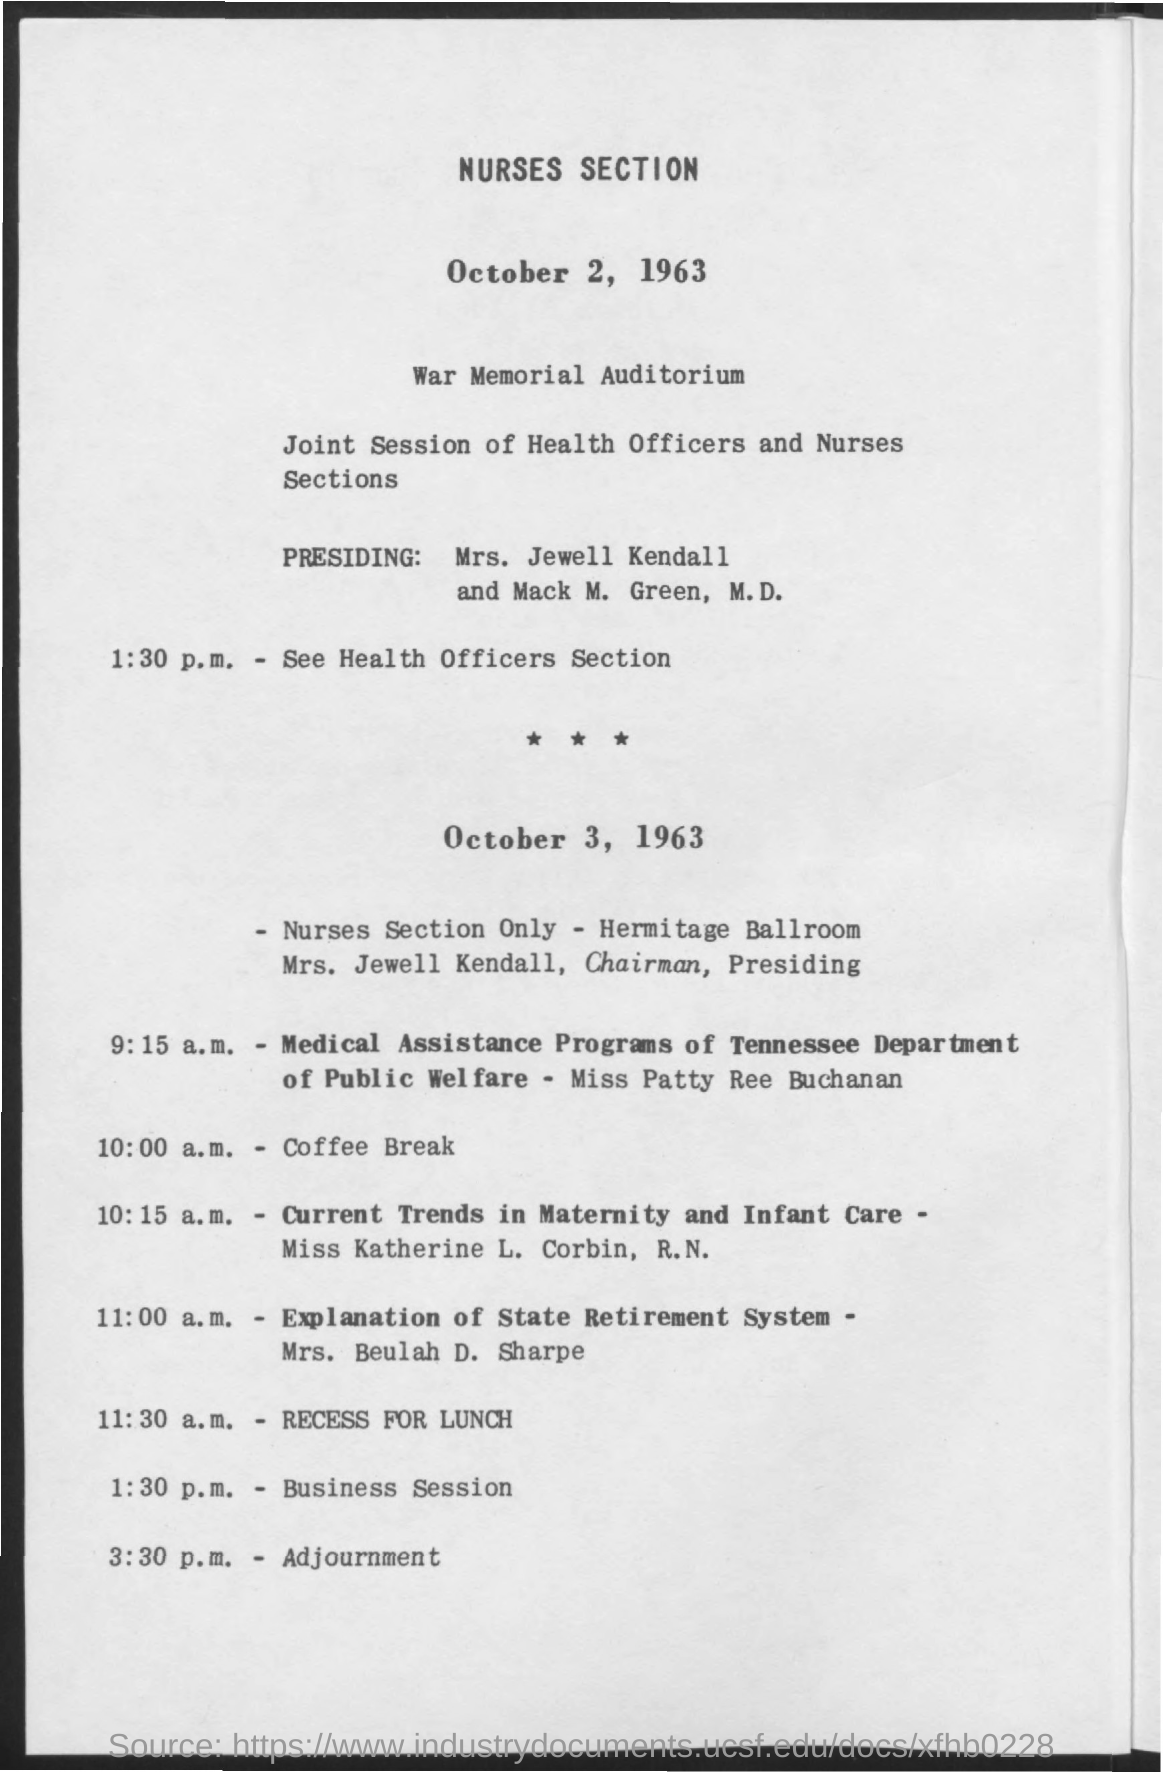Where is section held?
Offer a terse response. War Memorial Auditorium. When is the coffee break?
Offer a very short reply. 10:00 a.m. When is the recess for lunch?
Ensure brevity in your answer.  11:30 a.m. When is the Business Session?
Offer a very short reply. 1:30 p.m. When is the adjournment?
Provide a short and direct response. 3:30 p.m. 